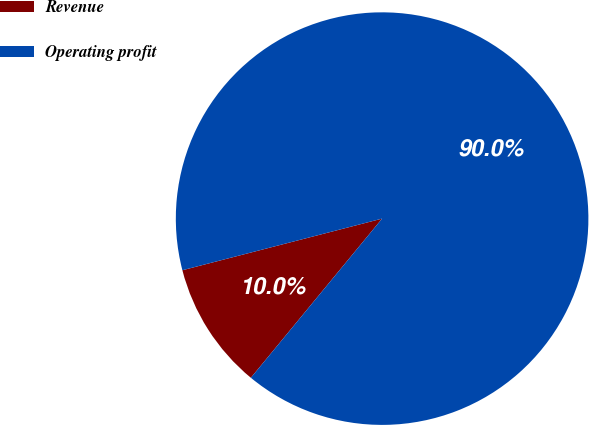<chart> <loc_0><loc_0><loc_500><loc_500><pie_chart><fcel>Revenue<fcel>Operating profit<nl><fcel>10.0%<fcel>90.0%<nl></chart> 